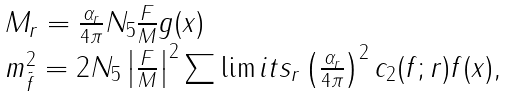<formula> <loc_0><loc_0><loc_500><loc_500>\begin{array} { l } M _ { r } = \frac { \alpha _ { r } } { 4 \pi } N _ { 5 } \frac { F } { M } g ( x ) \\ m _ { \tilde { f } } ^ { 2 } = 2 N _ { 5 } \left | \frac { F } { M } \right | ^ { 2 } \sum \lim i t s _ { r } \left ( \frac { \alpha _ { r } } { 4 \pi } \right ) ^ { 2 } c _ { 2 } ( f ; r ) f ( x ) , \end{array}</formula> 